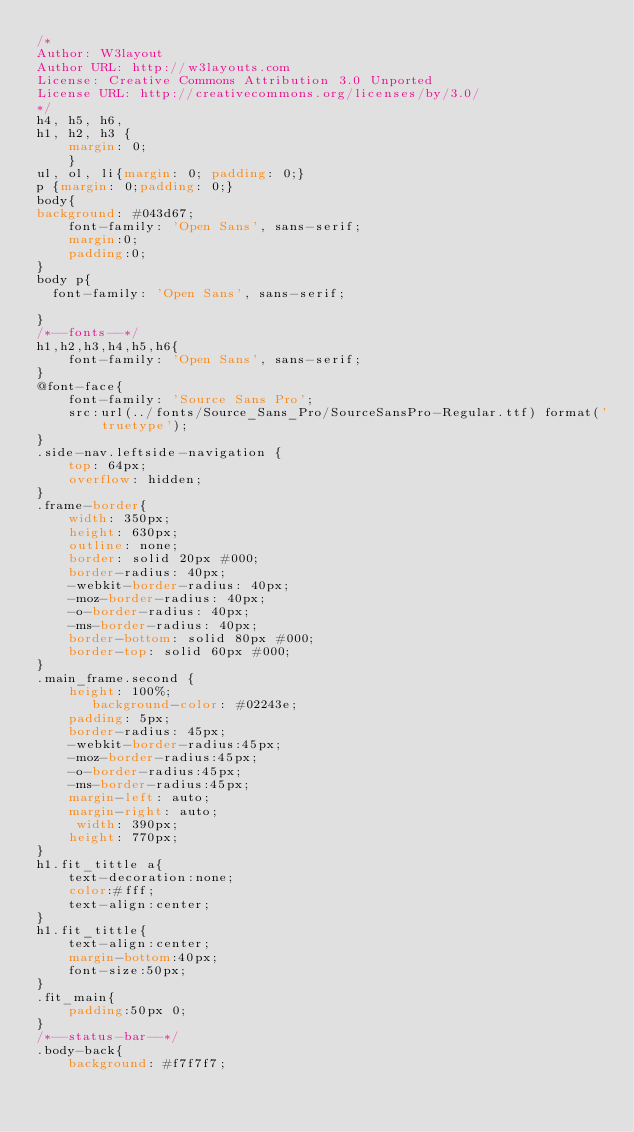<code> <loc_0><loc_0><loc_500><loc_500><_CSS_>/*
Author: W3layout
Author URL: http://w3layouts.com
License: Creative Commons Attribution 3.0 Unported
License URL: http://creativecommons.org/licenses/by/3.0/
*/
h4, h5, h6,
h1, h2, h3 {
	margin: 0;
	}
ul, ol, li{margin: 0; padding: 0;}
p {margin: 0;padding: 0;}
body{	
background: #043d67;
	font-family: 'Open Sans', sans-serif;
	margin:0;
	padding:0;
}
body p{
  font-family: 'Open Sans', sans-serif;
  
}
/*--fonts--*/
h1,h2,h3,h4,h5,h6{
	font-family: 'Open Sans', sans-serif;
}
@font-face{
	font-family: 'Source Sans Pro';
	src:url(../fonts/Source_Sans_Pro/SourceSansPro-Regular.ttf) format('truetype');
}
.side-nav.leftside-navigation {
    top: 64px;
    overflow: hidden;
}
.frame-border{
    width: 350px;
    height: 630px;
    outline: none;
	border: solid 20px #000;
    border-radius: 40px;
	-webkit-border-radius: 40px;
	-moz-border-radius: 40px;
	-o-border-radius: 40px;
	-ms-border-radius: 40px;
    border-bottom: solid 80px #000;
    border-top: solid 60px #000;
}
.main_frame.second {
    height: 100%;
       background-color: #02243e;
    padding: 5px;
    border-radius: 45px;
	-webkit-border-radius:45px;
	-moz-border-radius:45px;
	-o-border-radius:45px;
	-ms-border-radius:45px;
    margin-left: auto;
    margin-right: auto;
     width: 390px;
    height: 770px;
}
h1.fit_tittle a{
	text-decoration:none;
	color:#fff;
	text-align:center;
}
h1.fit_tittle{
	text-align:center;
	margin-bottom:40px;	
	font-size:50px;
}
.fit_main{
	padding:50px 0;
}
/*--status-bar--*/
.body-back{
    background: #f7f7f7;</code> 